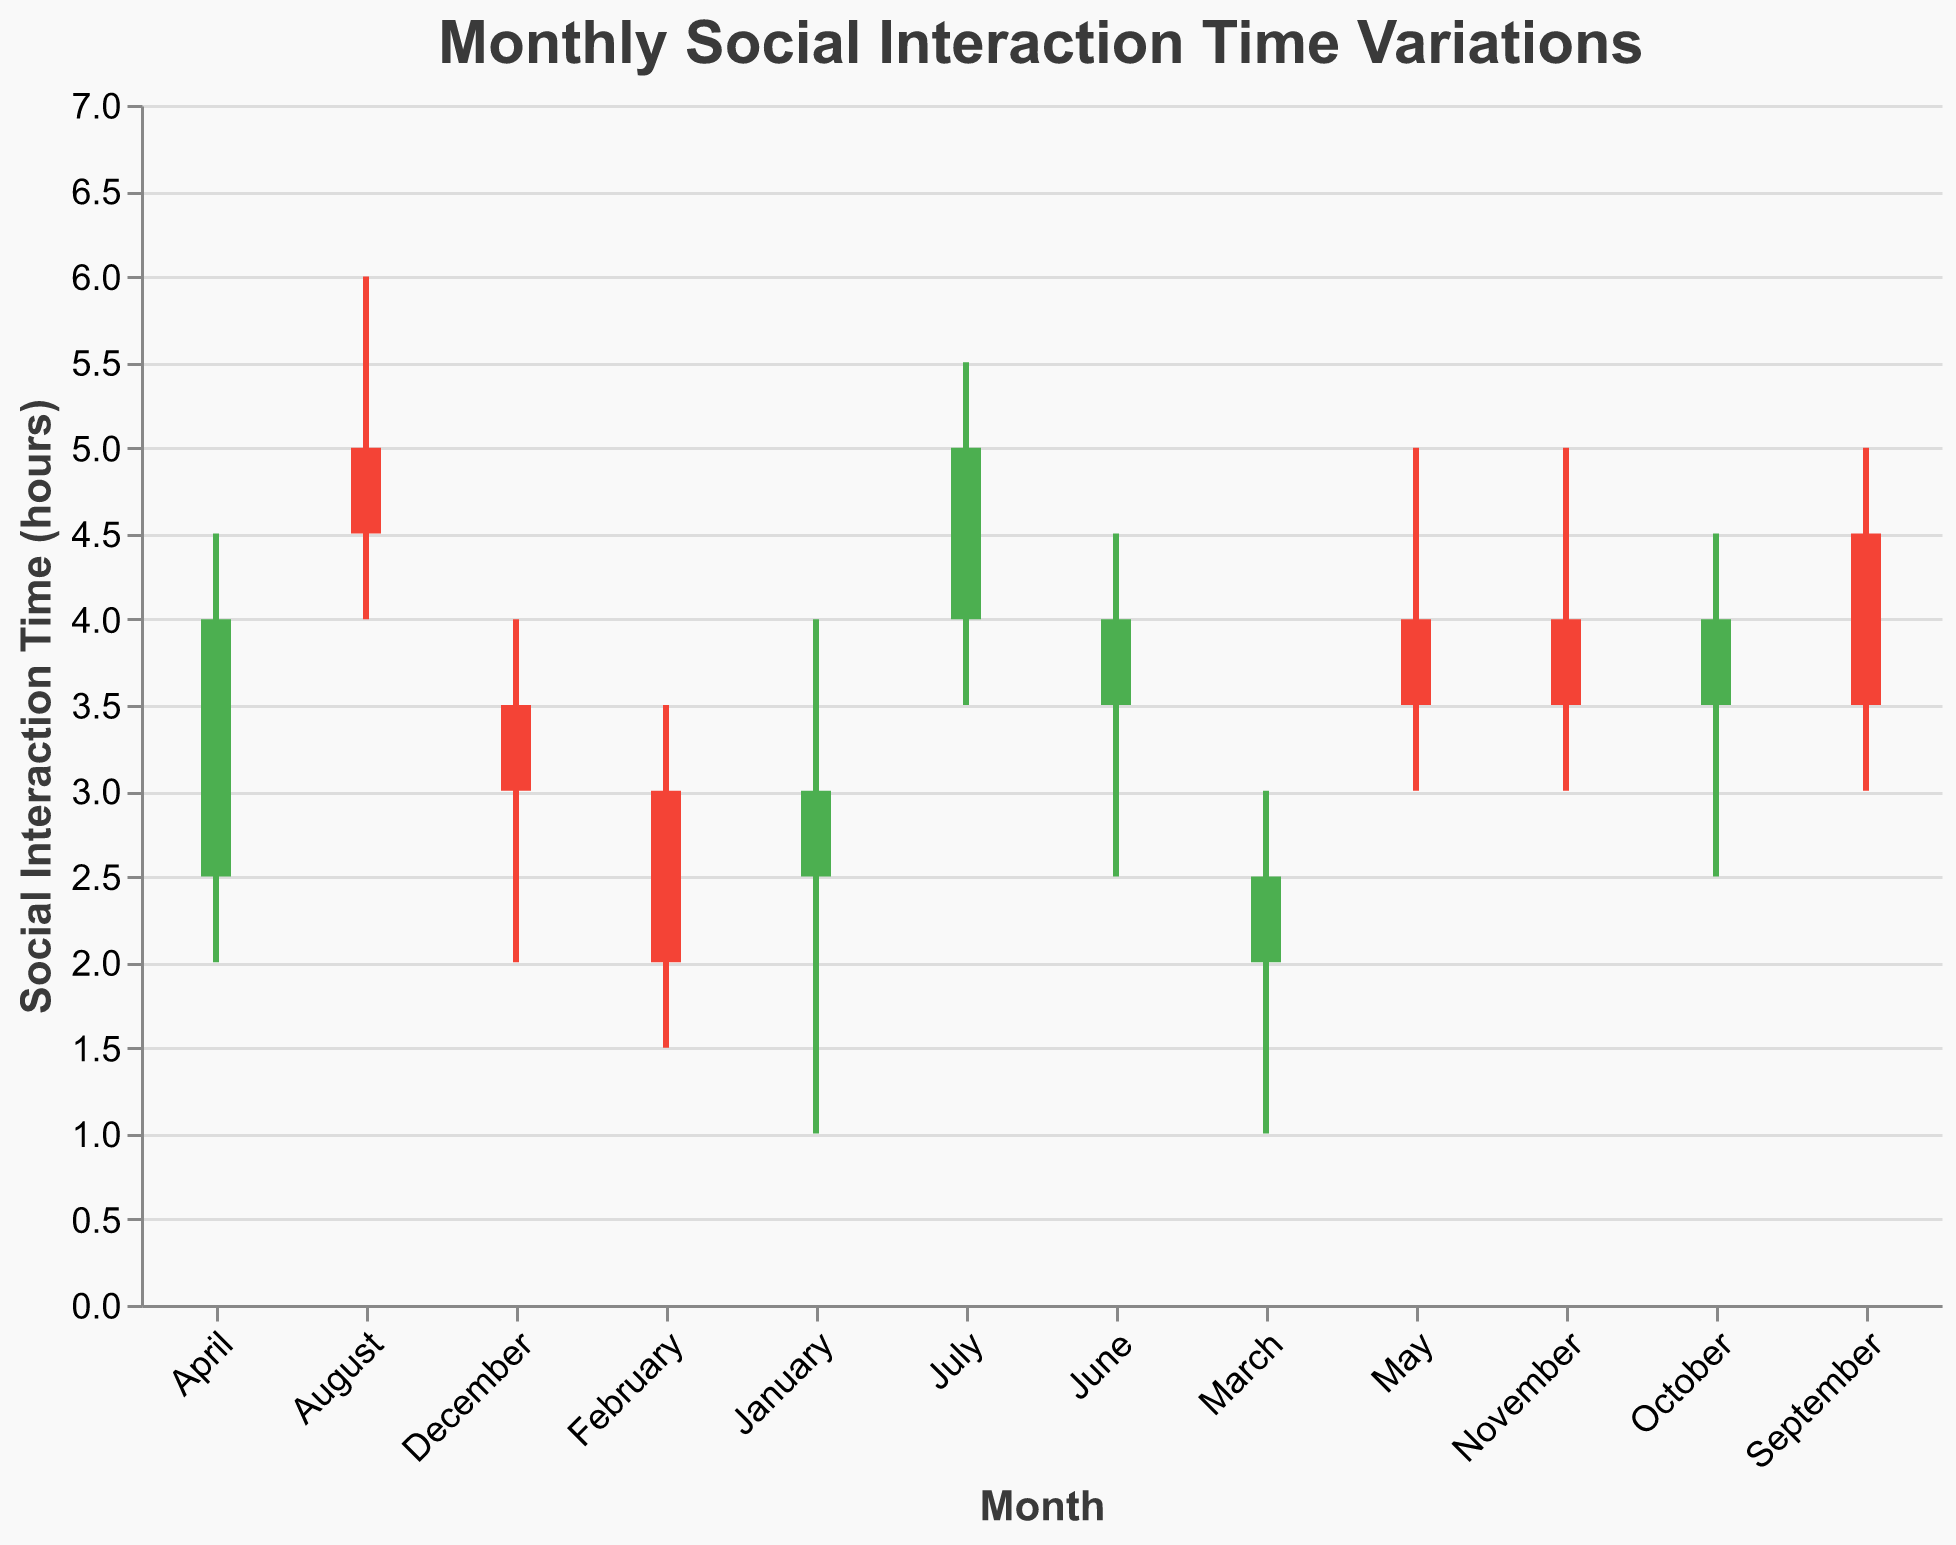What is the title of the chart? The title is typically located at the top of the chart in a larger font size and distinct color compared to other text elements. For this chart, the title is given directly in the code.
Answer: Monthly Social Interaction Time Variations Which month has the highest 'High' value for social interaction time? The 'High' value indicates the peak social interaction time for each month. By looking at the 'High' column, we can compare all months to find the highest value.
Answer: August In which month did the social interaction time decrease the most from open to close? The decrease is found by subtracting the 'Close' value from the 'Open' value for each month. We look for the largest negative difference.
Answer: February What is the average 'Close' value for the first quarter of the year? The first quarter includes January, February, and March. Calculate the average by summing the 'Close' values for these months and dividing by the number of months: (3.0 + 2.0 + 2.5) / 3.
Answer: 2.5 Compare the 'Open' value in January and July. Which one is higher? By directly comparing the 'Open' values for January (2.5) and July (4.0), we can determine which is higher.
Answer: July During which month did the social interaction time show the greatest range (difference between 'High' and 'Low')? The range is calculated for each month by subtracting the 'Low' value from the 'High' value. The month with the highest resultant value has the greatest range.
Answer: April Which months had a 'Close' value higher than their 'Open' value? Look for months where the 'Close' value is greater than the 'Open' value by comparing each pair in the data.
Answer: January, April, June, July, October What is the median 'Open' value for the entire year? To find the median, list all the 'Open' values: 2.5, 3.0, 2.0, 2.5, 4.0, 3.5, 4.0, 5.0, 4.5, 3.5, 4.0, 3.5, and find the middle value after sorting them.
Answer: 3.5 Analyzing the data, which month marks a distinct recovery period indicated by a significant increase in 'Close' values? A recovery period can be inferred from a noticeable jump in 'Close' values from the previous month. Compare the 'Close' values month by month to identify such a pattern.
Answer: April 